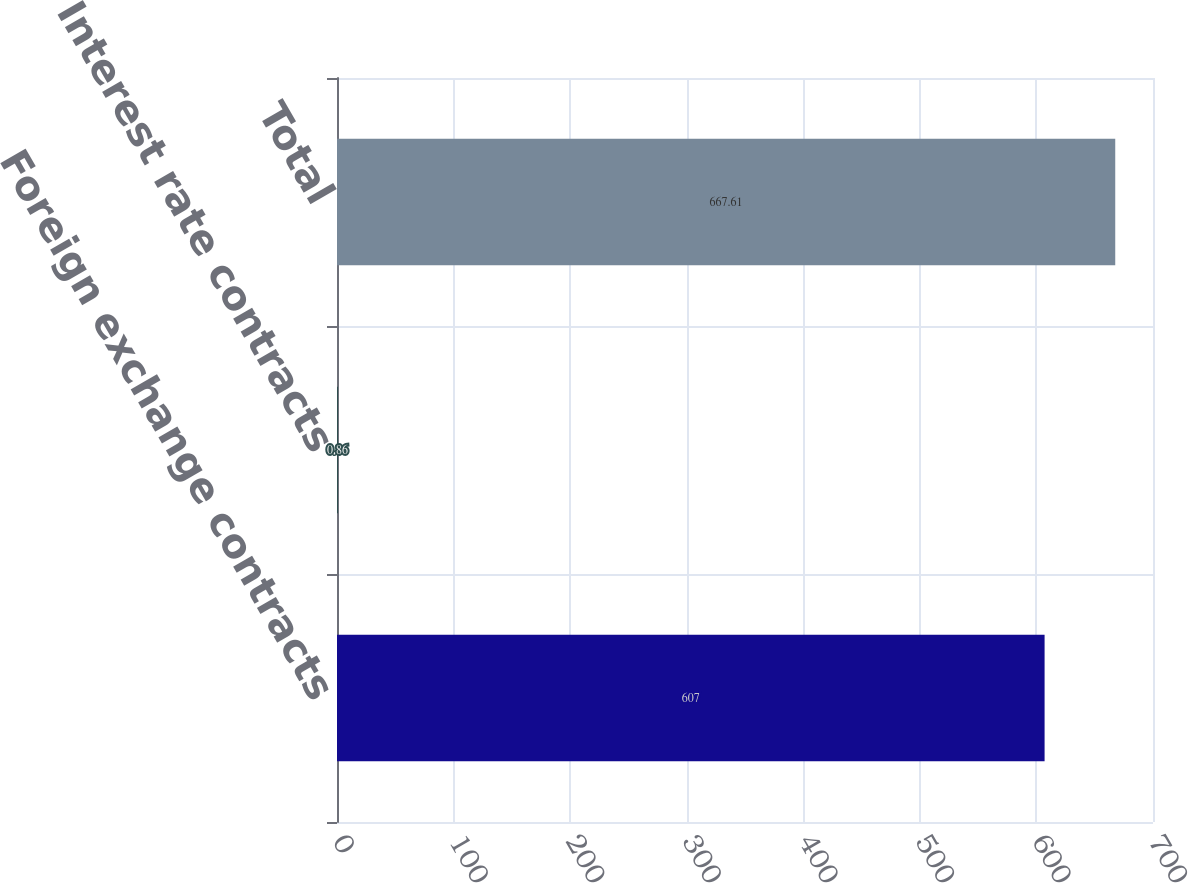Convert chart. <chart><loc_0><loc_0><loc_500><loc_500><bar_chart><fcel>Foreign exchange contracts<fcel>Interest rate contracts<fcel>Total<nl><fcel>607<fcel>0.86<fcel>667.61<nl></chart> 